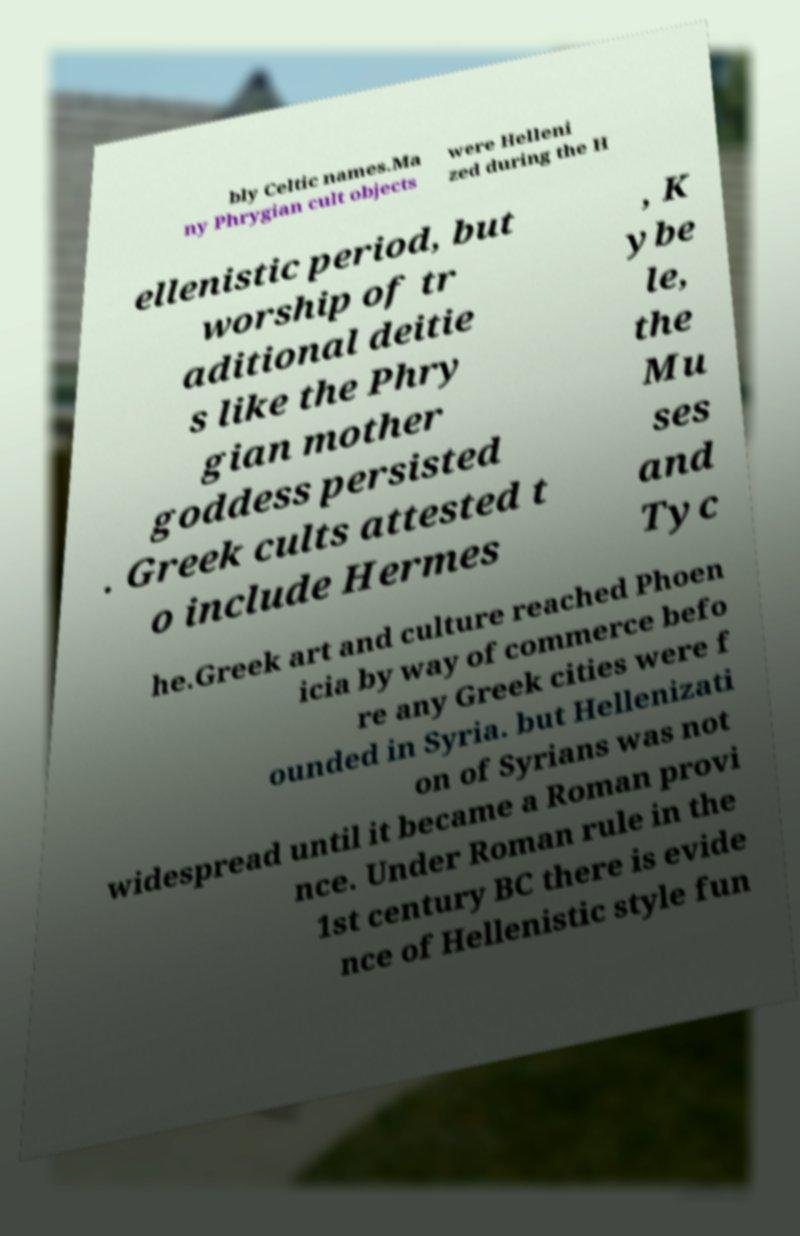I need the written content from this picture converted into text. Can you do that? bly Celtic names.Ma ny Phrygian cult objects were Helleni zed during the H ellenistic period, but worship of tr aditional deitie s like the Phry gian mother goddess persisted . Greek cults attested t o include Hermes , K ybe le, the Mu ses and Tyc he.Greek art and culture reached Phoen icia by way of commerce befo re any Greek cities were f ounded in Syria. but Hellenizati on of Syrians was not widespread until it became a Roman provi nce. Under Roman rule in the 1st century BC there is evide nce of Hellenistic style fun 